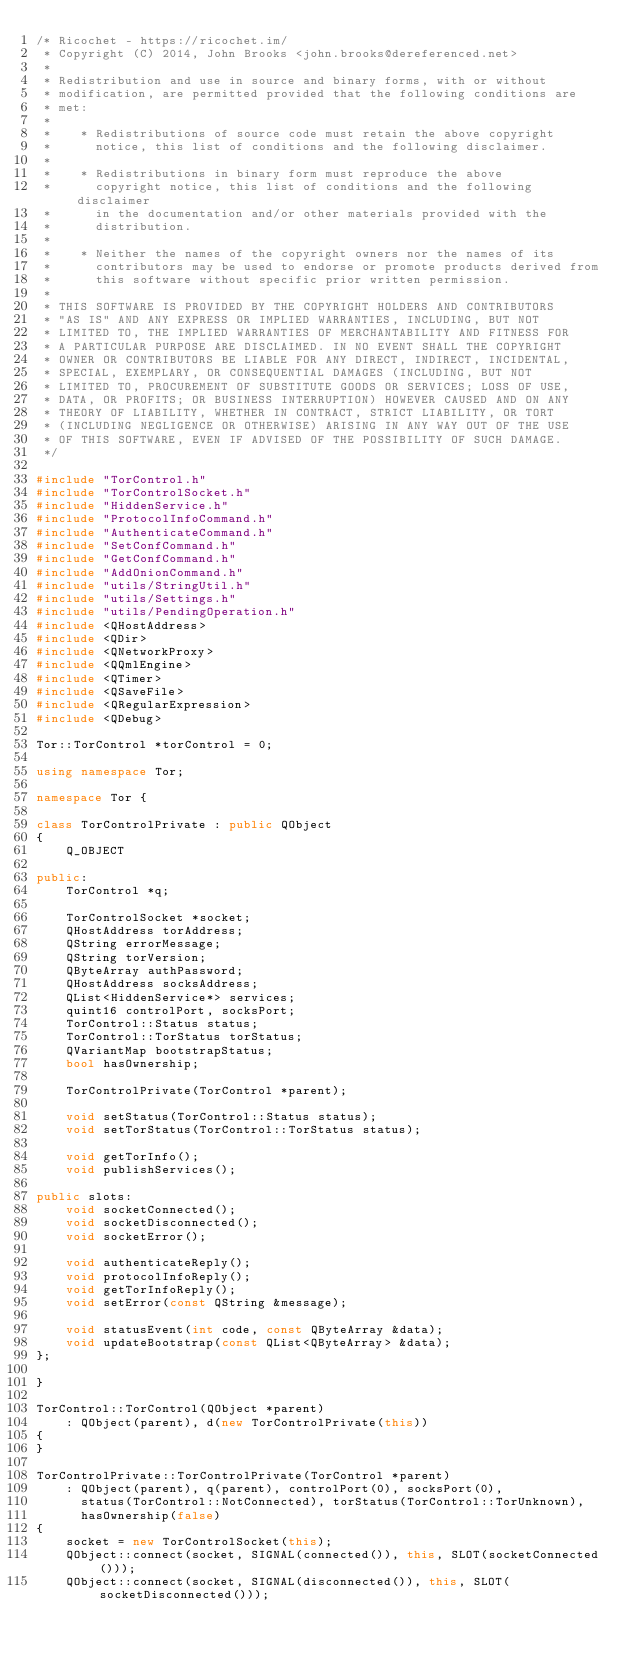Convert code to text. <code><loc_0><loc_0><loc_500><loc_500><_C++_>/* Ricochet - https://ricochet.im/
 * Copyright (C) 2014, John Brooks <john.brooks@dereferenced.net>
 *
 * Redistribution and use in source and binary forms, with or without
 * modification, are permitted provided that the following conditions are
 * met:
 *
 *    * Redistributions of source code must retain the above copyright
 *      notice, this list of conditions and the following disclaimer.
 *
 *    * Redistributions in binary form must reproduce the above
 *      copyright notice, this list of conditions and the following disclaimer
 *      in the documentation and/or other materials provided with the
 *      distribution.
 *
 *    * Neither the names of the copyright owners nor the names of its
 *      contributors may be used to endorse or promote products derived from
 *      this software without specific prior written permission.
 *
 * THIS SOFTWARE IS PROVIDED BY THE COPYRIGHT HOLDERS AND CONTRIBUTORS
 * "AS IS" AND ANY EXPRESS OR IMPLIED WARRANTIES, INCLUDING, BUT NOT
 * LIMITED TO, THE IMPLIED WARRANTIES OF MERCHANTABILITY AND FITNESS FOR
 * A PARTICULAR PURPOSE ARE DISCLAIMED. IN NO EVENT SHALL THE COPYRIGHT
 * OWNER OR CONTRIBUTORS BE LIABLE FOR ANY DIRECT, INDIRECT, INCIDENTAL,
 * SPECIAL, EXEMPLARY, OR CONSEQUENTIAL DAMAGES (INCLUDING, BUT NOT
 * LIMITED TO, PROCUREMENT OF SUBSTITUTE GOODS OR SERVICES; LOSS OF USE,
 * DATA, OR PROFITS; OR BUSINESS INTERRUPTION) HOWEVER CAUSED AND ON ANY
 * THEORY OF LIABILITY, WHETHER IN CONTRACT, STRICT LIABILITY, OR TORT
 * (INCLUDING NEGLIGENCE OR OTHERWISE) ARISING IN ANY WAY OUT OF THE USE
 * OF THIS SOFTWARE, EVEN IF ADVISED OF THE POSSIBILITY OF SUCH DAMAGE.
 */

#include "TorControl.h"
#include "TorControlSocket.h"
#include "HiddenService.h"
#include "ProtocolInfoCommand.h"
#include "AuthenticateCommand.h"
#include "SetConfCommand.h"
#include "GetConfCommand.h"
#include "AddOnionCommand.h"
#include "utils/StringUtil.h"
#include "utils/Settings.h"
#include "utils/PendingOperation.h"
#include <QHostAddress>
#include <QDir>
#include <QNetworkProxy>
#include <QQmlEngine>
#include <QTimer>
#include <QSaveFile>
#include <QRegularExpression>
#include <QDebug>

Tor::TorControl *torControl = 0;

using namespace Tor;

namespace Tor {

class TorControlPrivate : public QObject
{
    Q_OBJECT

public:
    TorControl *q;

    TorControlSocket *socket;
    QHostAddress torAddress;
    QString errorMessage;
    QString torVersion;
    QByteArray authPassword;
    QHostAddress socksAddress;
    QList<HiddenService*> services;
    quint16 controlPort, socksPort;
    TorControl::Status status;
    TorControl::TorStatus torStatus;
    QVariantMap bootstrapStatus;
    bool hasOwnership;

    TorControlPrivate(TorControl *parent);

    void setStatus(TorControl::Status status);
    void setTorStatus(TorControl::TorStatus status);

    void getTorInfo();
    void publishServices();

public slots:
    void socketConnected();
    void socketDisconnected();
    void socketError();

    void authenticateReply();
    void protocolInfoReply();
    void getTorInfoReply();
    void setError(const QString &message);

    void statusEvent(int code, const QByteArray &data);
    void updateBootstrap(const QList<QByteArray> &data);
};

}

TorControl::TorControl(QObject *parent)
    : QObject(parent), d(new TorControlPrivate(this))
{
}

TorControlPrivate::TorControlPrivate(TorControl *parent)
    : QObject(parent), q(parent), controlPort(0), socksPort(0),
      status(TorControl::NotConnected), torStatus(TorControl::TorUnknown),
      hasOwnership(false)
{
    socket = new TorControlSocket(this);
    QObject::connect(socket, SIGNAL(connected()), this, SLOT(socketConnected()));
    QObject::connect(socket, SIGNAL(disconnected()), this, SLOT(socketDisconnected()));</code> 